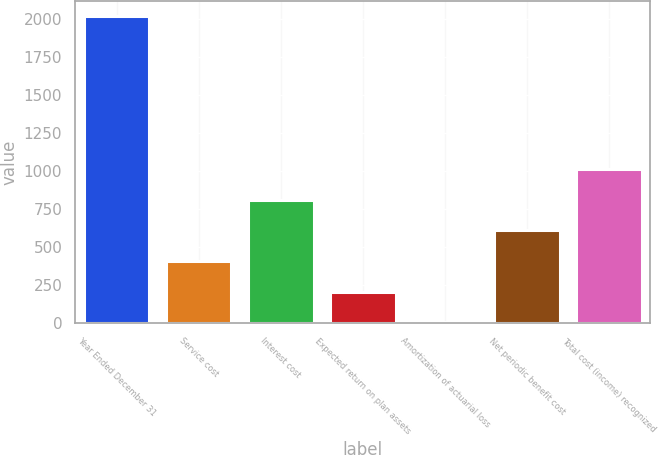<chart> <loc_0><loc_0><loc_500><loc_500><bar_chart><fcel>Year Ended December 31<fcel>Service cost<fcel>Interest cost<fcel>Expected return on plan assets<fcel>Amortization of actuarial loss<fcel>Net periodic benefit cost<fcel>Total cost (income) recognized<nl><fcel>2017<fcel>409.8<fcel>811.6<fcel>208.9<fcel>8<fcel>610.7<fcel>1012.5<nl></chart> 